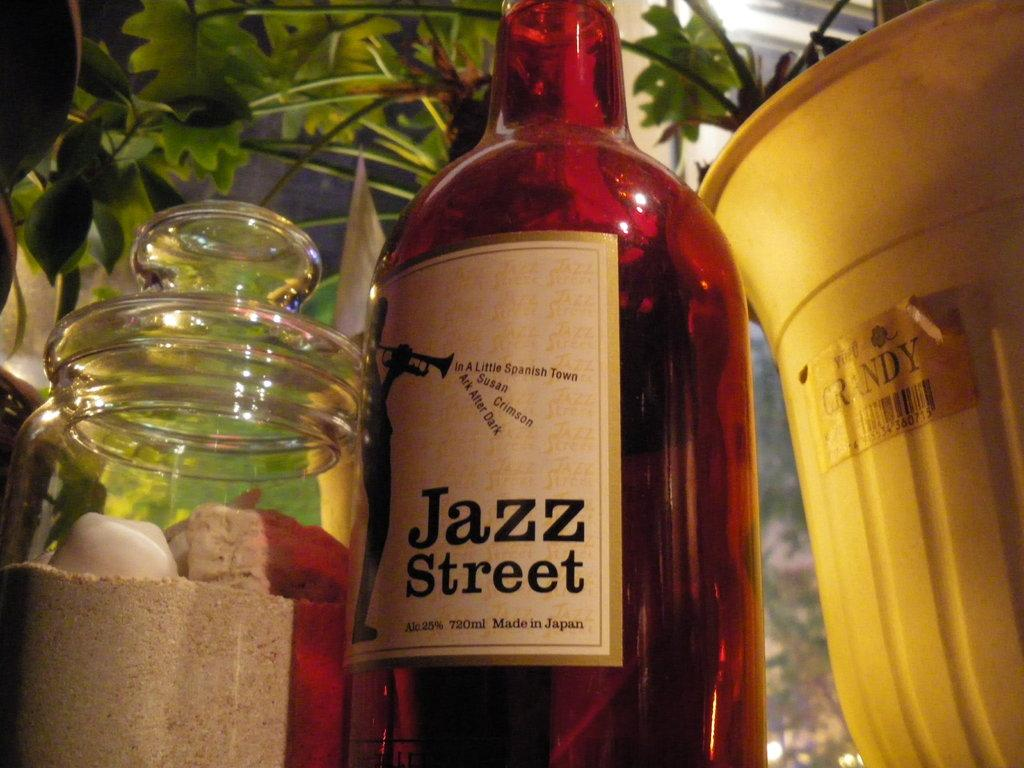<image>
Relay a brief, clear account of the picture shown. A jazz street bottle rests next to a jar 